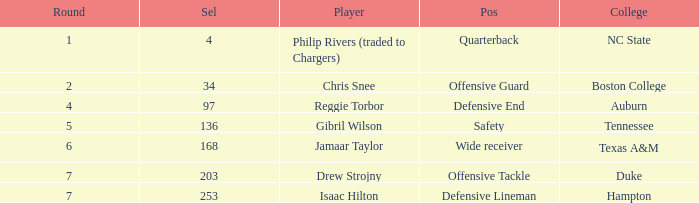Which Position has a Round larger than 5, and a Selection of 168? Wide receiver. 